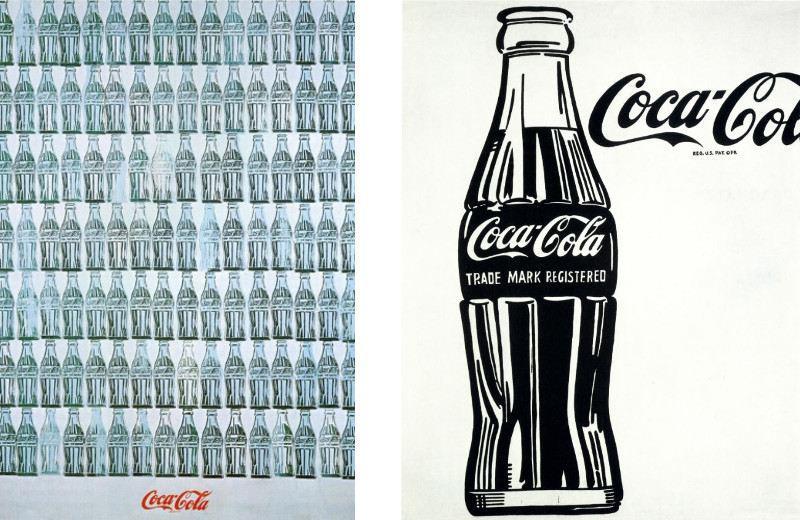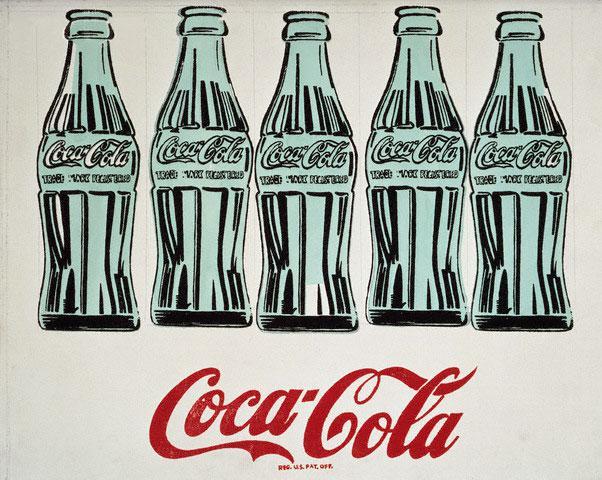The first image is the image on the left, the second image is the image on the right. Given the left and right images, does the statement "There are four bottles of soda." hold true? Answer yes or no. No. The first image is the image on the left, the second image is the image on the right. For the images shown, is this caption "The artwork in the image on the right depicts exactly three bottles." true? Answer yes or no. No. 